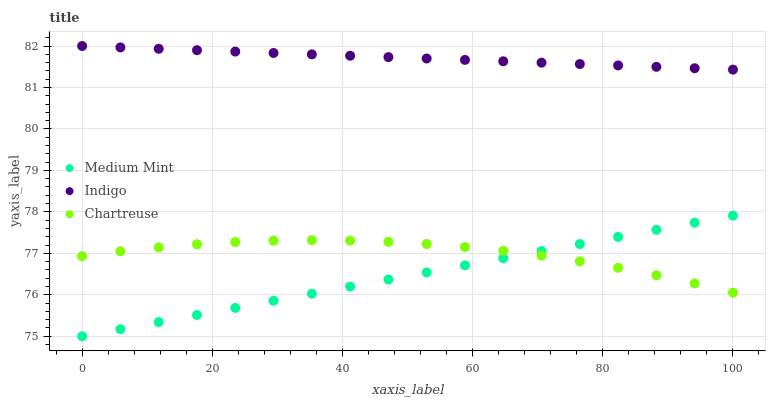Does Medium Mint have the minimum area under the curve?
Answer yes or no. Yes. Does Indigo have the maximum area under the curve?
Answer yes or no. Yes. Does Chartreuse have the minimum area under the curve?
Answer yes or no. No. Does Chartreuse have the maximum area under the curve?
Answer yes or no. No. Is Medium Mint the smoothest?
Answer yes or no. Yes. Is Chartreuse the roughest?
Answer yes or no. Yes. Is Indigo the smoothest?
Answer yes or no. No. Is Indigo the roughest?
Answer yes or no. No. Does Medium Mint have the lowest value?
Answer yes or no. Yes. Does Chartreuse have the lowest value?
Answer yes or no. No. Does Indigo have the highest value?
Answer yes or no. Yes. Does Chartreuse have the highest value?
Answer yes or no. No. Is Medium Mint less than Indigo?
Answer yes or no. Yes. Is Indigo greater than Medium Mint?
Answer yes or no. Yes. Does Medium Mint intersect Chartreuse?
Answer yes or no. Yes. Is Medium Mint less than Chartreuse?
Answer yes or no. No. Is Medium Mint greater than Chartreuse?
Answer yes or no. No. Does Medium Mint intersect Indigo?
Answer yes or no. No. 